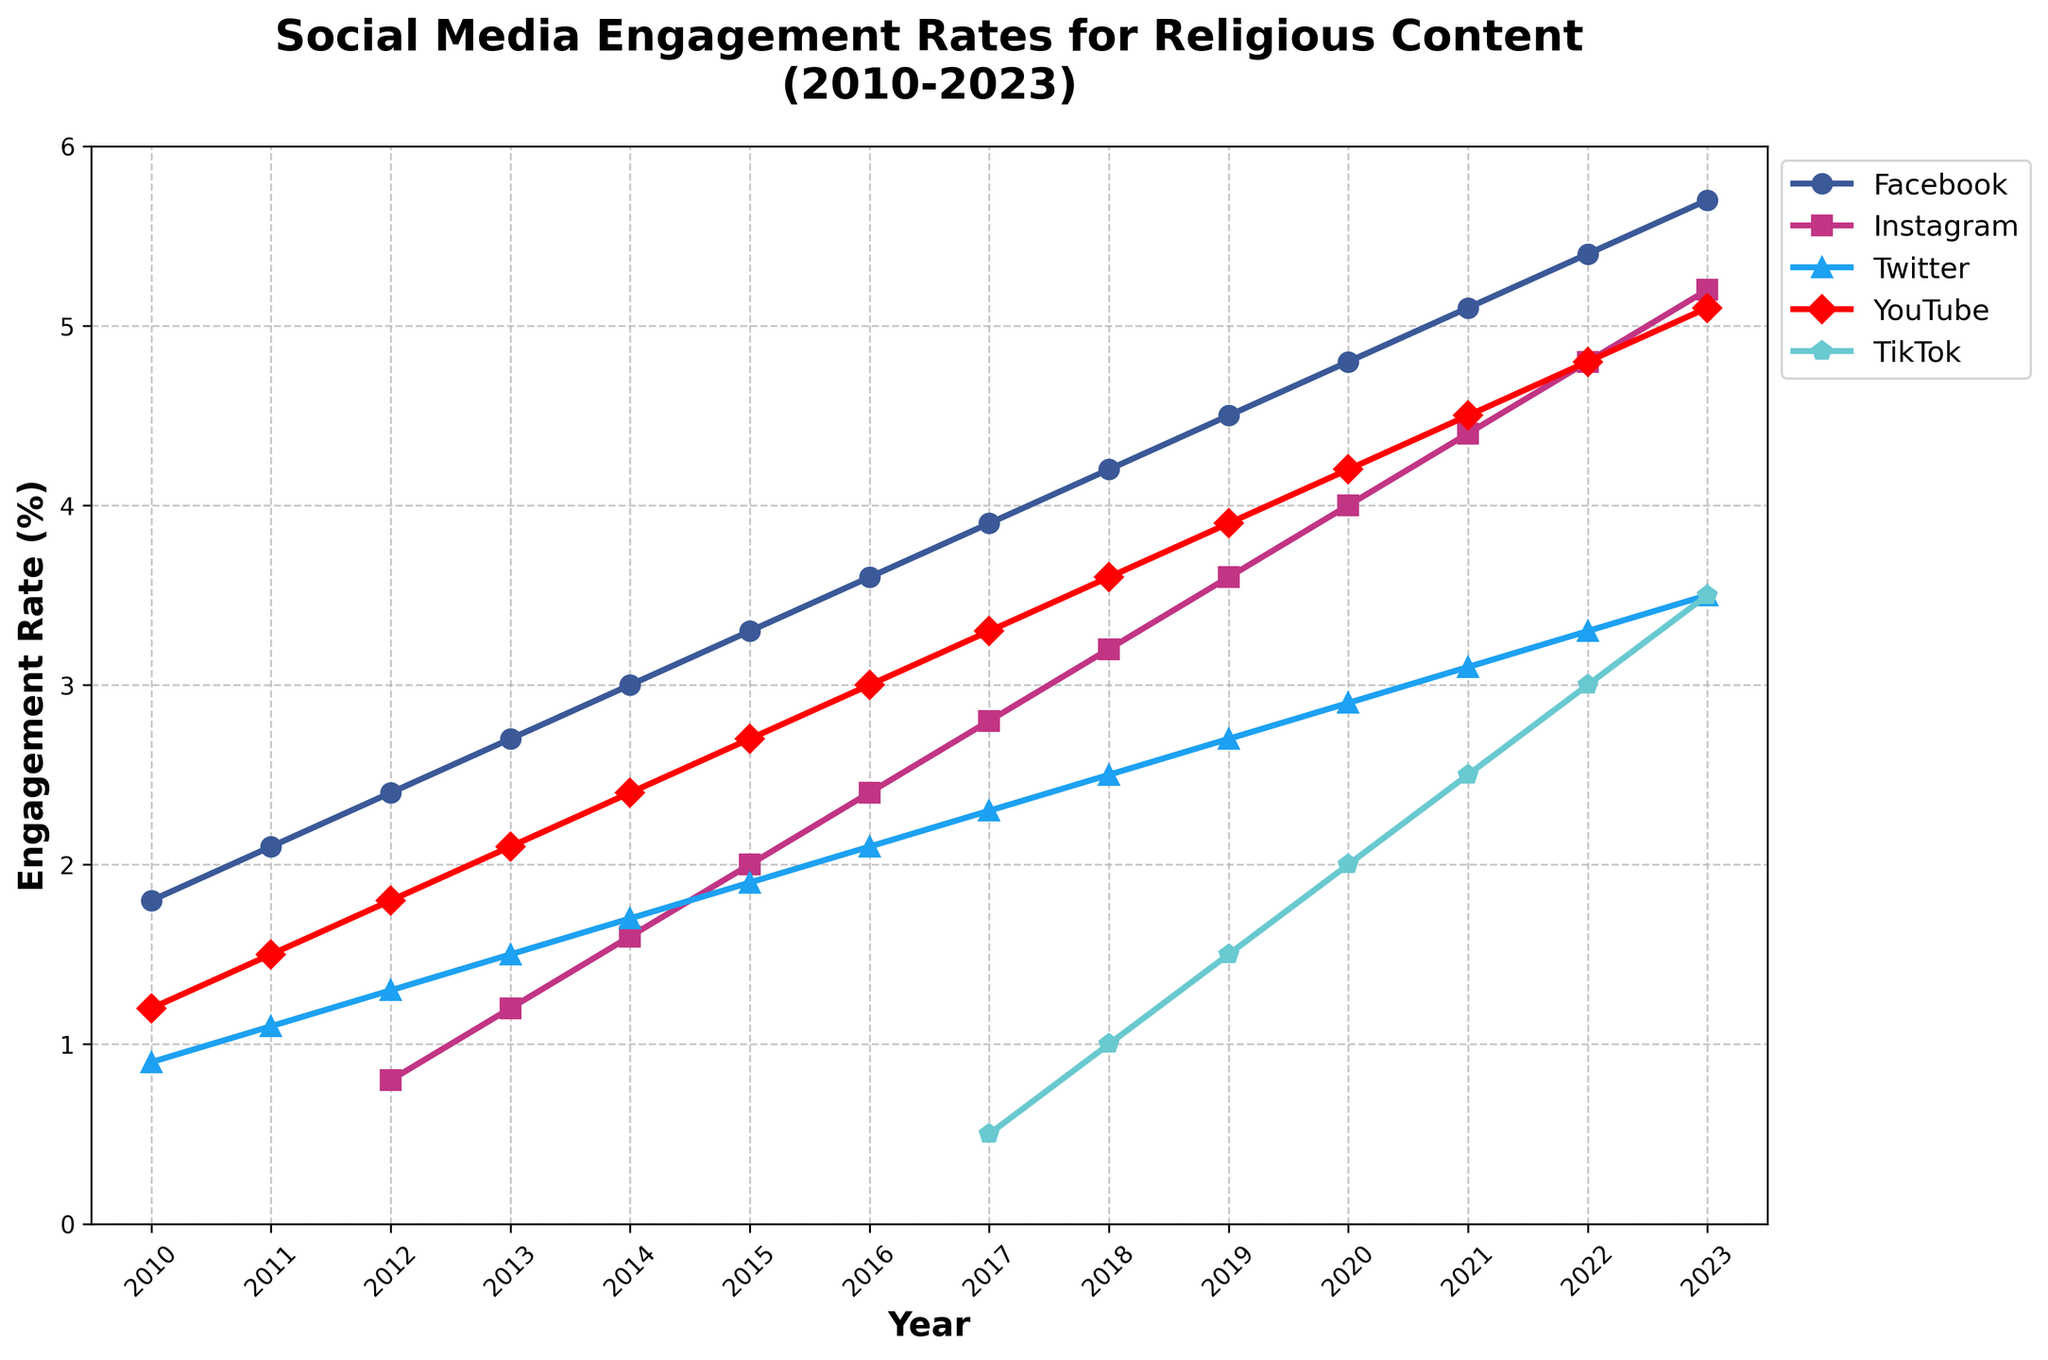What year did Instagram first appear in the dataset? Instagram appears in the dataset starting in 2012. Looking at the figure, Instagram has data starting in 2012.
Answer: 2012 Which platform had the highest engagement rate in 2010? According to the figure, Facebook had the highest engagement rate in 2010 with 1.8%. By checking the highest value among all platforms for the year 2010, we see Facebook standing out.
Answer: Facebook What is the difference in engagement rates between Facebook and Instagram in 2023? In 2023, Facebook's engagement rate is 5.7% and Instagram's is 5.2%. The difference is 5.7% - 5.2% = 0.5%.
Answer: 0.5% How did TikTok's engagement rate change from 2018 to 2023? TikTok's engagement rate increased from 1.0% in 2018 to 3.5% in 2023. The change equals 3.5% - 1.0% = 2.5%.
Answer: Increased by 2.5% Did YouTube's engagement rate ever fall below 2% between 2010 and 2023? No, YouTube's engagement rate did not fall below 2% between 2010 and 2023. It was consistently 1.2% or higher from 2010 to 2023 as shown in the figure.
Answer: No Which platform showed the most significant growth in engagement rate from 2010 to 2023? Facebook showed the most significant growth, increasing from 1.8% in 2010 to 5.7% in 2023. By looking at the growth trajectory of each platform, Facebook's increase is the largest.
Answer: Facebook In what year did Twitter's engagement rate reach 2%? Twitter's engagement rate reached 2% in 2015. By looking at the progression of Twitter's engagement rates over the years, it hits 2% in 2015.
Answer: 2015 What is the average engagement rate for YouTube over the entire period? To calculate the average engagement rate for YouTube from 2010 to 2023, sum up all the yearly values and divide by the number of years: (1.2% + 1.5% + 1.8% + 2.1% + 2.4% + 2.7% + 3.0% + 3.3% + 3.6% + 3.9% + 4.2% + 4.5% + 4.8% + 5.1%) / 14 ≈ 3.0%.
Answer: 3.0% Which year did Facebook's engagement rate surpass 4%? Facebook's engagement rate surpassed 4% in 2018. By checking the values of Facebook over the years, it crosses the 4% mark in 2018.
Answer: 2018 